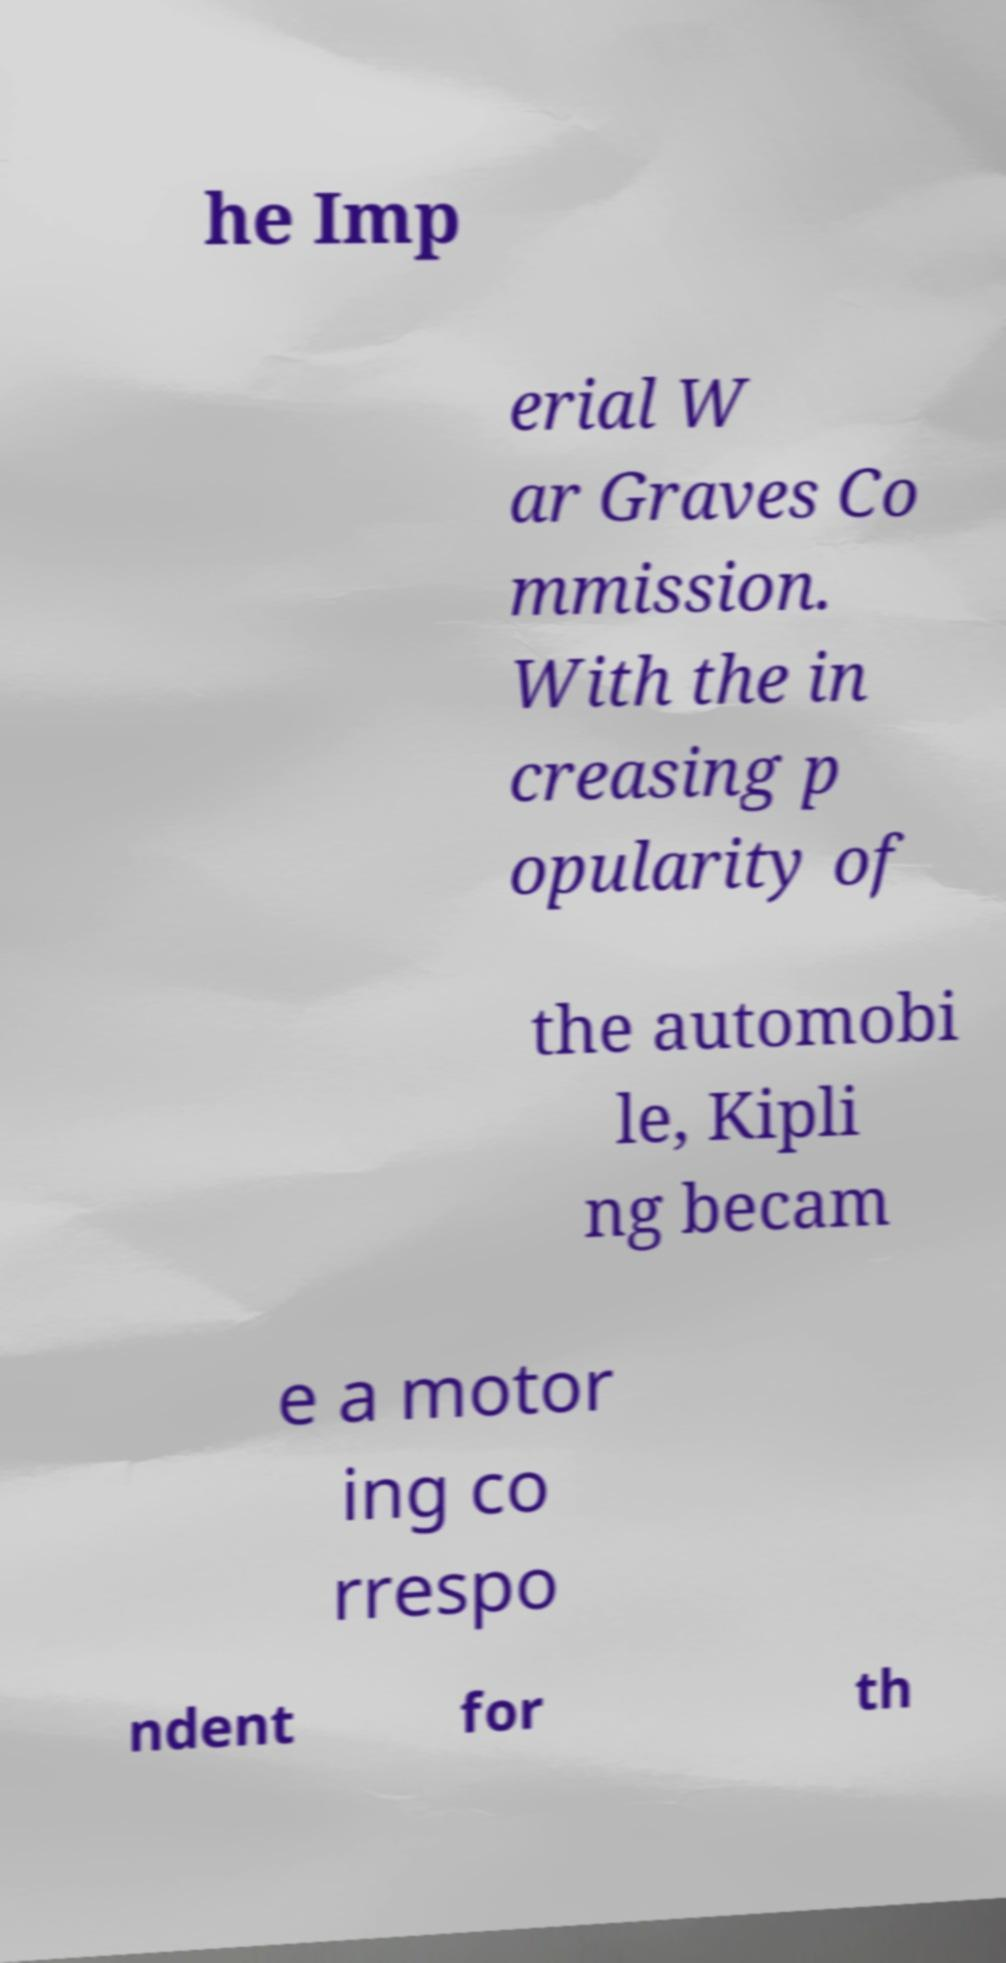There's text embedded in this image that I need extracted. Can you transcribe it verbatim? he Imp erial W ar Graves Co mmission. With the in creasing p opularity of the automobi le, Kipli ng becam e a motor ing co rrespo ndent for th 